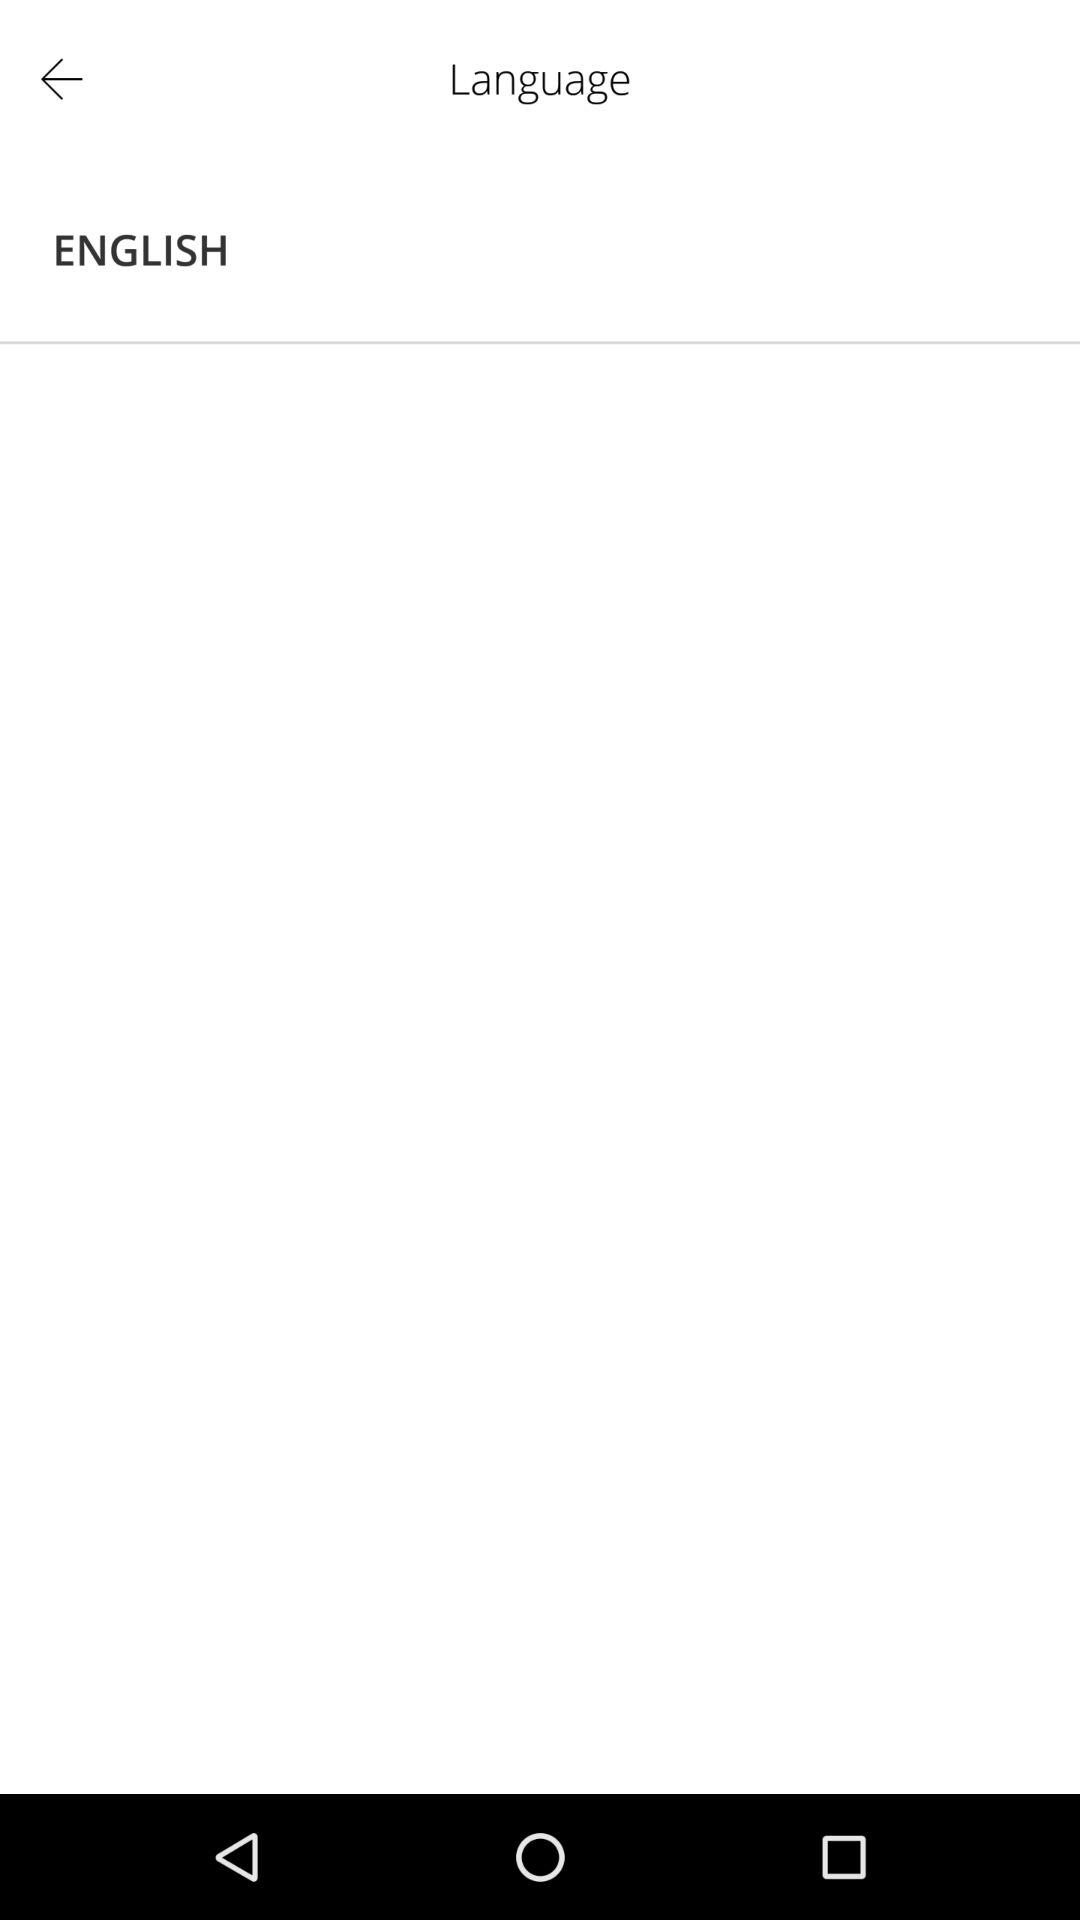Which language is mentioned? The mentioned language is English. 